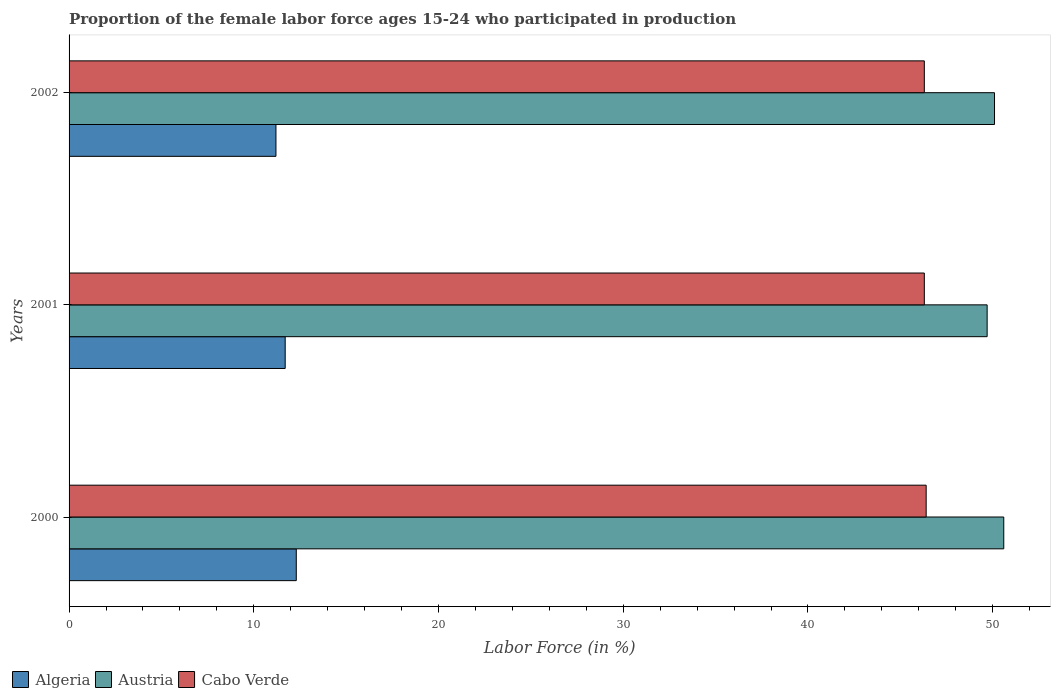How many groups of bars are there?
Offer a terse response. 3. Are the number of bars per tick equal to the number of legend labels?
Ensure brevity in your answer.  Yes. How many bars are there on the 3rd tick from the top?
Keep it short and to the point. 3. How many bars are there on the 2nd tick from the bottom?
Your response must be concise. 3. What is the label of the 2nd group of bars from the top?
Your response must be concise. 2001. In how many cases, is the number of bars for a given year not equal to the number of legend labels?
Provide a short and direct response. 0. What is the proportion of the female labor force who participated in production in Cabo Verde in 2000?
Offer a very short reply. 46.4. Across all years, what is the maximum proportion of the female labor force who participated in production in Cabo Verde?
Your answer should be compact. 46.4. Across all years, what is the minimum proportion of the female labor force who participated in production in Algeria?
Offer a very short reply. 11.2. What is the total proportion of the female labor force who participated in production in Austria in the graph?
Offer a terse response. 150.4. What is the difference between the proportion of the female labor force who participated in production in Cabo Verde in 2000 and that in 2001?
Make the answer very short. 0.1. What is the difference between the proportion of the female labor force who participated in production in Cabo Verde in 2000 and the proportion of the female labor force who participated in production in Austria in 2001?
Offer a terse response. -3.3. What is the average proportion of the female labor force who participated in production in Cabo Verde per year?
Provide a succinct answer. 46.33. In the year 2002, what is the difference between the proportion of the female labor force who participated in production in Cabo Verde and proportion of the female labor force who participated in production in Algeria?
Keep it short and to the point. 35.1. What is the ratio of the proportion of the female labor force who participated in production in Algeria in 2001 to that in 2002?
Give a very brief answer. 1.04. What is the difference between the highest and the lowest proportion of the female labor force who participated in production in Cabo Verde?
Your answer should be very brief. 0.1. Is the sum of the proportion of the female labor force who participated in production in Algeria in 2001 and 2002 greater than the maximum proportion of the female labor force who participated in production in Austria across all years?
Offer a very short reply. No. What does the 3rd bar from the bottom in 2002 represents?
Your answer should be very brief. Cabo Verde. Is it the case that in every year, the sum of the proportion of the female labor force who participated in production in Austria and proportion of the female labor force who participated in production in Algeria is greater than the proportion of the female labor force who participated in production in Cabo Verde?
Keep it short and to the point. Yes. How many years are there in the graph?
Keep it short and to the point. 3. Are the values on the major ticks of X-axis written in scientific E-notation?
Offer a very short reply. No. Does the graph contain any zero values?
Your response must be concise. No. Where does the legend appear in the graph?
Keep it short and to the point. Bottom left. How many legend labels are there?
Ensure brevity in your answer.  3. What is the title of the graph?
Your answer should be very brief. Proportion of the female labor force ages 15-24 who participated in production. Does "Denmark" appear as one of the legend labels in the graph?
Your answer should be compact. No. What is the Labor Force (in %) in Algeria in 2000?
Give a very brief answer. 12.3. What is the Labor Force (in %) in Austria in 2000?
Make the answer very short. 50.6. What is the Labor Force (in %) of Cabo Verde in 2000?
Provide a succinct answer. 46.4. What is the Labor Force (in %) in Algeria in 2001?
Offer a terse response. 11.7. What is the Labor Force (in %) of Austria in 2001?
Your answer should be very brief. 49.7. What is the Labor Force (in %) in Cabo Verde in 2001?
Your answer should be compact. 46.3. What is the Labor Force (in %) of Algeria in 2002?
Your response must be concise. 11.2. What is the Labor Force (in %) in Austria in 2002?
Your answer should be compact. 50.1. What is the Labor Force (in %) in Cabo Verde in 2002?
Your answer should be very brief. 46.3. Across all years, what is the maximum Labor Force (in %) in Algeria?
Your response must be concise. 12.3. Across all years, what is the maximum Labor Force (in %) in Austria?
Your answer should be compact. 50.6. Across all years, what is the maximum Labor Force (in %) in Cabo Verde?
Give a very brief answer. 46.4. Across all years, what is the minimum Labor Force (in %) of Algeria?
Offer a terse response. 11.2. Across all years, what is the minimum Labor Force (in %) of Austria?
Offer a very short reply. 49.7. Across all years, what is the minimum Labor Force (in %) in Cabo Verde?
Provide a succinct answer. 46.3. What is the total Labor Force (in %) in Algeria in the graph?
Offer a very short reply. 35.2. What is the total Labor Force (in %) of Austria in the graph?
Give a very brief answer. 150.4. What is the total Labor Force (in %) in Cabo Verde in the graph?
Keep it short and to the point. 139. What is the difference between the Labor Force (in %) of Austria in 2000 and that in 2001?
Offer a terse response. 0.9. What is the difference between the Labor Force (in %) in Algeria in 2000 and that in 2002?
Ensure brevity in your answer.  1.1. What is the difference between the Labor Force (in %) of Algeria in 2001 and that in 2002?
Your answer should be very brief. 0.5. What is the difference between the Labor Force (in %) of Algeria in 2000 and the Labor Force (in %) of Austria in 2001?
Your response must be concise. -37.4. What is the difference between the Labor Force (in %) in Algeria in 2000 and the Labor Force (in %) in Cabo Verde in 2001?
Your answer should be compact. -34. What is the difference between the Labor Force (in %) in Algeria in 2000 and the Labor Force (in %) in Austria in 2002?
Offer a very short reply. -37.8. What is the difference between the Labor Force (in %) in Algeria in 2000 and the Labor Force (in %) in Cabo Verde in 2002?
Your answer should be very brief. -34. What is the difference between the Labor Force (in %) of Austria in 2000 and the Labor Force (in %) of Cabo Verde in 2002?
Offer a very short reply. 4.3. What is the difference between the Labor Force (in %) of Algeria in 2001 and the Labor Force (in %) of Austria in 2002?
Your answer should be very brief. -38.4. What is the difference between the Labor Force (in %) of Algeria in 2001 and the Labor Force (in %) of Cabo Verde in 2002?
Your response must be concise. -34.6. What is the average Labor Force (in %) of Algeria per year?
Your response must be concise. 11.73. What is the average Labor Force (in %) in Austria per year?
Provide a succinct answer. 50.13. What is the average Labor Force (in %) of Cabo Verde per year?
Provide a short and direct response. 46.33. In the year 2000, what is the difference between the Labor Force (in %) of Algeria and Labor Force (in %) of Austria?
Offer a terse response. -38.3. In the year 2000, what is the difference between the Labor Force (in %) in Algeria and Labor Force (in %) in Cabo Verde?
Provide a succinct answer. -34.1. In the year 2001, what is the difference between the Labor Force (in %) in Algeria and Labor Force (in %) in Austria?
Your answer should be very brief. -38. In the year 2001, what is the difference between the Labor Force (in %) of Algeria and Labor Force (in %) of Cabo Verde?
Your response must be concise. -34.6. In the year 2001, what is the difference between the Labor Force (in %) in Austria and Labor Force (in %) in Cabo Verde?
Your answer should be very brief. 3.4. In the year 2002, what is the difference between the Labor Force (in %) in Algeria and Labor Force (in %) in Austria?
Your answer should be compact. -38.9. In the year 2002, what is the difference between the Labor Force (in %) in Algeria and Labor Force (in %) in Cabo Verde?
Offer a terse response. -35.1. In the year 2002, what is the difference between the Labor Force (in %) in Austria and Labor Force (in %) in Cabo Verde?
Keep it short and to the point. 3.8. What is the ratio of the Labor Force (in %) in Algeria in 2000 to that in 2001?
Ensure brevity in your answer.  1.05. What is the ratio of the Labor Force (in %) of Austria in 2000 to that in 2001?
Keep it short and to the point. 1.02. What is the ratio of the Labor Force (in %) of Cabo Verde in 2000 to that in 2001?
Your response must be concise. 1. What is the ratio of the Labor Force (in %) in Algeria in 2000 to that in 2002?
Ensure brevity in your answer.  1.1. What is the ratio of the Labor Force (in %) of Cabo Verde in 2000 to that in 2002?
Provide a short and direct response. 1. What is the ratio of the Labor Force (in %) of Algeria in 2001 to that in 2002?
Give a very brief answer. 1.04. What is the ratio of the Labor Force (in %) in Austria in 2001 to that in 2002?
Provide a short and direct response. 0.99. What is the difference between the highest and the second highest Labor Force (in %) of Cabo Verde?
Offer a terse response. 0.1. What is the difference between the highest and the lowest Labor Force (in %) of Algeria?
Provide a short and direct response. 1.1. 